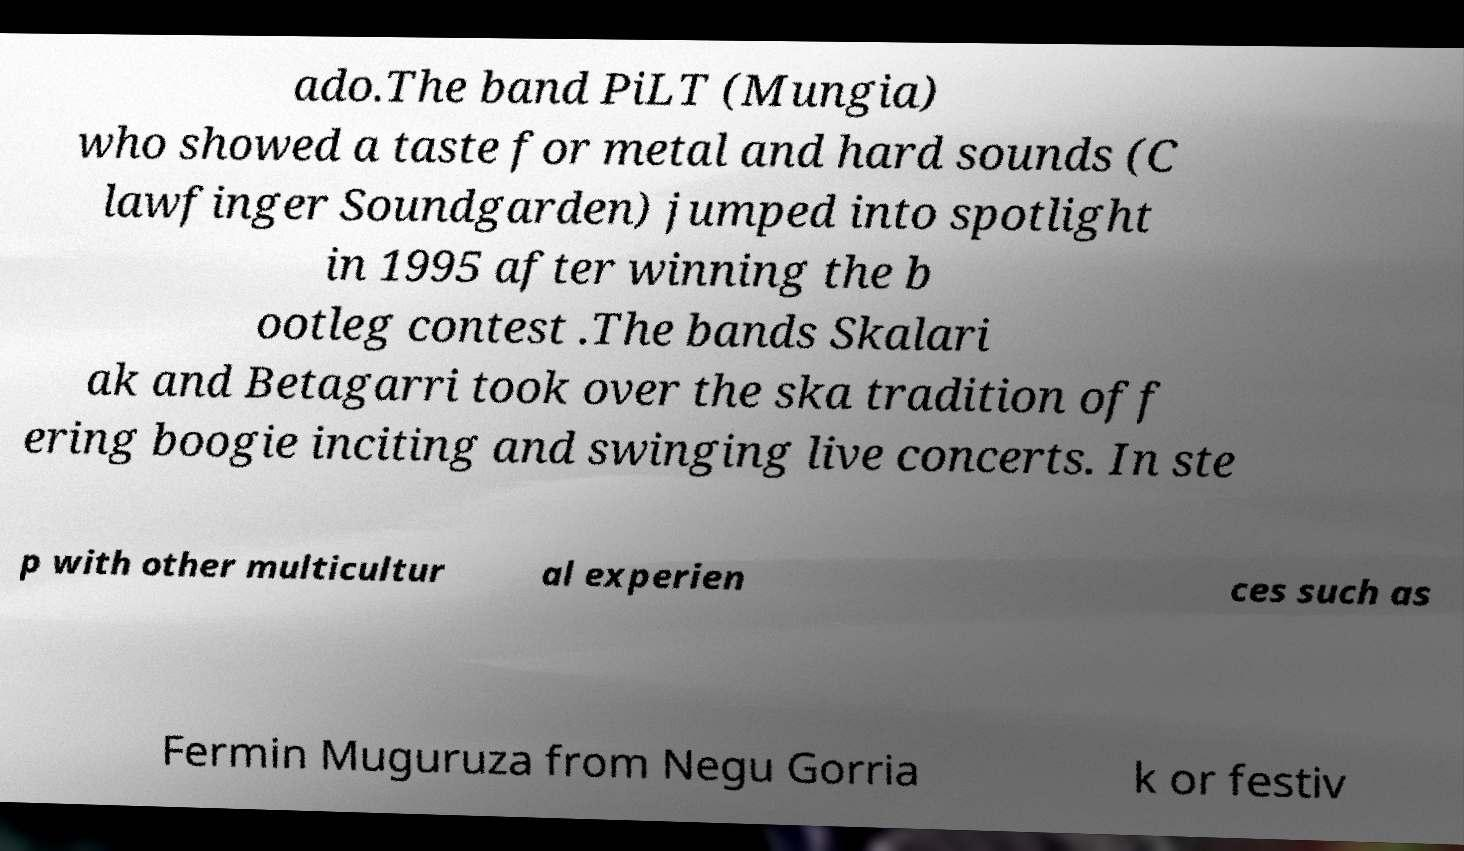Please read and relay the text visible in this image. What does it say? ado.The band PiLT (Mungia) who showed a taste for metal and hard sounds (C lawfinger Soundgarden) jumped into spotlight in 1995 after winning the b ootleg contest .The bands Skalari ak and Betagarri took over the ska tradition off ering boogie inciting and swinging live concerts. In ste p with other multicultur al experien ces such as Fermin Muguruza from Negu Gorria k or festiv 